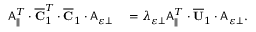<formula> <loc_0><loc_0><loc_500><loc_500>\begin{array} { r l } { A _ { \| } ^ { T } \cdot \overline { C } _ { 1 } ^ { T } \cdot \overline { C } _ { 1 } \cdot A _ { \varepsilon \perp } } & = \lambda _ { \varepsilon \perp } A _ { \| } ^ { T } \cdot \overline { U } _ { 1 } \cdot A _ { \varepsilon \perp } . } \end{array}</formula> 